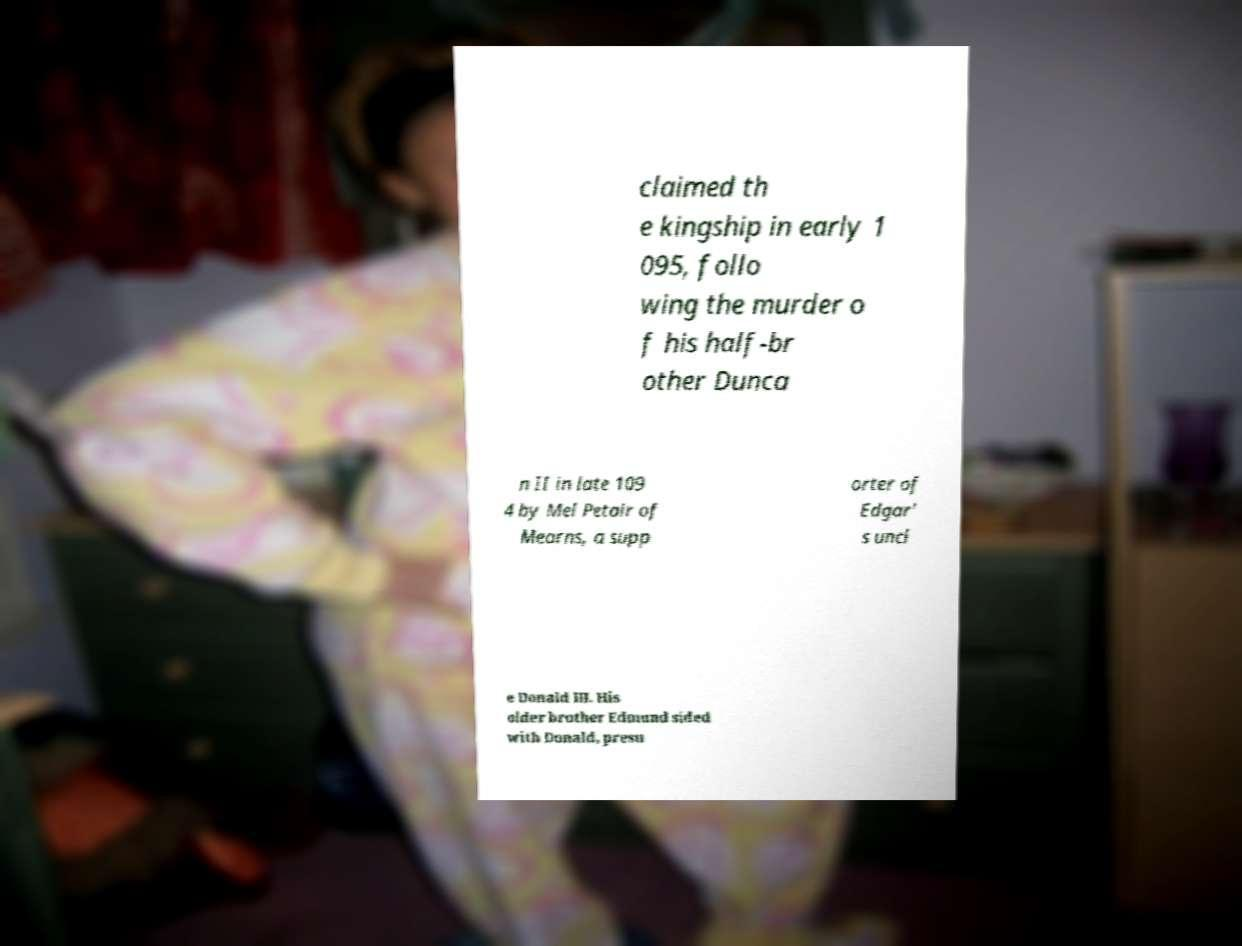Could you extract and type out the text from this image? claimed th e kingship in early 1 095, follo wing the murder o f his half-br other Dunca n II in late 109 4 by Mel Petair of Mearns, a supp orter of Edgar' s uncl e Donald III. His older brother Edmund sided with Donald, presu 